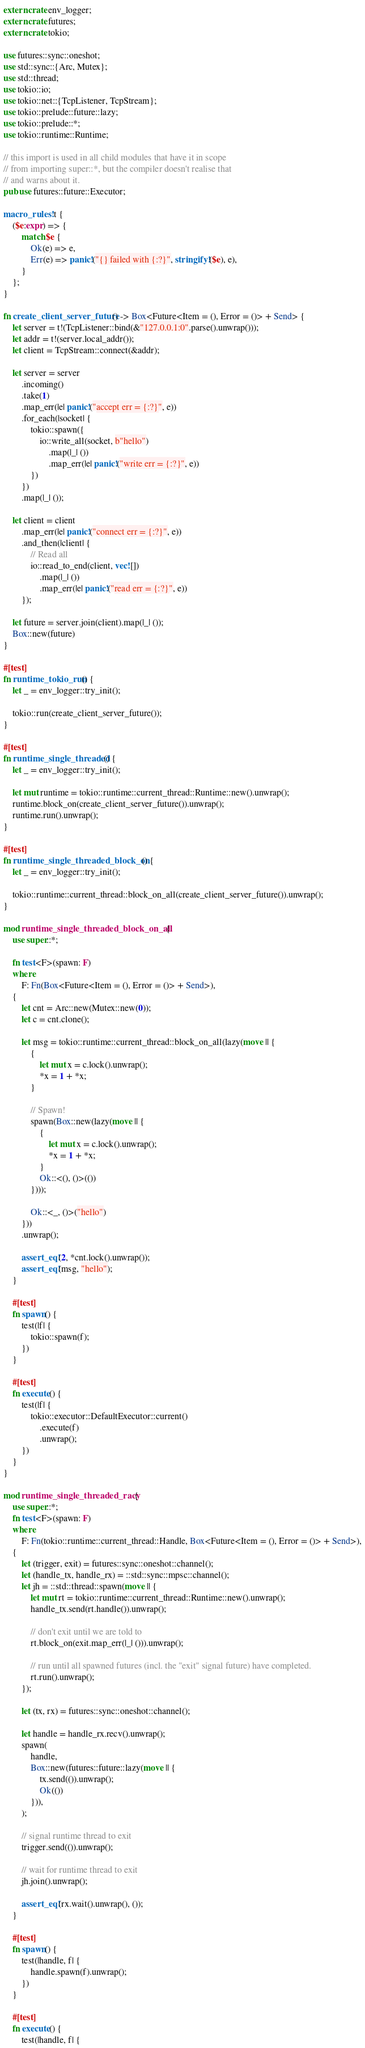<code> <loc_0><loc_0><loc_500><loc_500><_Rust_>extern crate env_logger;
extern crate futures;
extern crate tokio;

use futures::sync::oneshot;
use std::sync::{Arc, Mutex};
use std::thread;
use tokio::io;
use tokio::net::{TcpListener, TcpStream};
use tokio::prelude::future::lazy;
use tokio::prelude::*;
use tokio::runtime::Runtime;

// this import is used in all child modules that have it in scope
// from importing super::*, but the compiler doesn't realise that
// and warns about it.
pub use futures::future::Executor;

macro_rules! t {
    ($e:expr) => {
        match $e {
            Ok(e) => e,
            Err(e) => panic!("{} failed with {:?}", stringify!($e), e),
        }
    };
}

fn create_client_server_future() -> Box<Future<Item = (), Error = ()> + Send> {
    let server = t!(TcpListener::bind(&"127.0.0.1:0".parse().unwrap()));
    let addr = t!(server.local_addr());
    let client = TcpStream::connect(&addr);

    let server = server
        .incoming()
        .take(1)
        .map_err(|e| panic!("accept err = {:?}", e))
        .for_each(|socket| {
            tokio::spawn({
                io::write_all(socket, b"hello")
                    .map(|_| ())
                    .map_err(|e| panic!("write err = {:?}", e))
            })
        })
        .map(|_| ());

    let client = client
        .map_err(|e| panic!("connect err = {:?}", e))
        .and_then(|client| {
            // Read all
            io::read_to_end(client, vec![])
                .map(|_| ())
                .map_err(|e| panic!("read err = {:?}", e))
        });

    let future = server.join(client).map(|_| ());
    Box::new(future)
}

#[test]
fn runtime_tokio_run() {
    let _ = env_logger::try_init();

    tokio::run(create_client_server_future());
}

#[test]
fn runtime_single_threaded() {
    let _ = env_logger::try_init();

    let mut runtime = tokio::runtime::current_thread::Runtime::new().unwrap();
    runtime.block_on(create_client_server_future()).unwrap();
    runtime.run().unwrap();
}

#[test]
fn runtime_single_threaded_block_on() {
    let _ = env_logger::try_init();

    tokio::runtime::current_thread::block_on_all(create_client_server_future()).unwrap();
}

mod runtime_single_threaded_block_on_all {
    use super::*;

    fn test<F>(spawn: F)
    where
        F: Fn(Box<Future<Item = (), Error = ()> + Send>),
    {
        let cnt = Arc::new(Mutex::new(0));
        let c = cnt.clone();

        let msg = tokio::runtime::current_thread::block_on_all(lazy(move || {
            {
                let mut x = c.lock().unwrap();
                *x = 1 + *x;
            }

            // Spawn!
            spawn(Box::new(lazy(move || {
                {
                    let mut x = c.lock().unwrap();
                    *x = 1 + *x;
                }
                Ok::<(), ()>(())
            })));

            Ok::<_, ()>("hello")
        }))
        .unwrap();

        assert_eq!(2, *cnt.lock().unwrap());
        assert_eq!(msg, "hello");
    }

    #[test]
    fn spawn() {
        test(|f| {
            tokio::spawn(f);
        })
    }

    #[test]
    fn execute() {
        test(|f| {
            tokio::executor::DefaultExecutor::current()
                .execute(f)
                .unwrap();
        })
    }
}

mod runtime_single_threaded_racy {
    use super::*;
    fn test<F>(spawn: F)
    where
        F: Fn(tokio::runtime::current_thread::Handle, Box<Future<Item = (), Error = ()> + Send>),
    {
        let (trigger, exit) = futures::sync::oneshot::channel();
        let (handle_tx, handle_rx) = ::std::sync::mpsc::channel();
        let jh = ::std::thread::spawn(move || {
            let mut rt = tokio::runtime::current_thread::Runtime::new().unwrap();
            handle_tx.send(rt.handle()).unwrap();

            // don't exit until we are told to
            rt.block_on(exit.map_err(|_| ())).unwrap();

            // run until all spawned futures (incl. the "exit" signal future) have completed.
            rt.run().unwrap();
        });

        let (tx, rx) = futures::sync::oneshot::channel();

        let handle = handle_rx.recv().unwrap();
        spawn(
            handle,
            Box::new(futures::future::lazy(move || {
                tx.send(()).unwrap();
                Ok(())
            })),
        );

        // signal runtime thread to exit
        trigger.send(()).unwrap();

        // wait for runtime thread to exit
        jh.join().unwrap();

        assert_eq!(rx.wait().unwrap(), ());
    }

    #[test]
    fn spawn() {
        test(|handle, f| {
            handle.spawn(f).unwrap();
        })
    }

    #[test]
    fn execute() {
        test(|handle, f| {</code> 